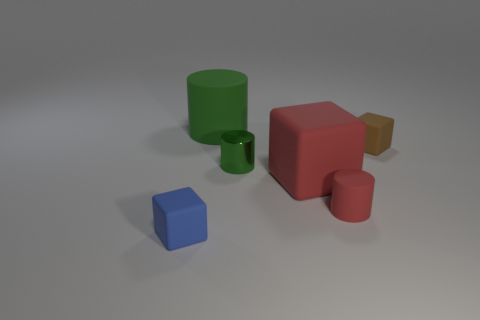What color is the other cylinder that is the same size as the green metallic cylinder?
Provide a short and direct response. Red. What shape is the matte thing that is the same color as the shiny thing?
Make the answer very short. Cylinder. Is the tiny red matte object the same shape as the green metallic thing?
Your answer should be very brief. Yes. There is a object that is to the left of the small green metal cylinder and behind the blue rubber block; what material is it made of?
Your answer should be compact. Rubber. What is the size of the blue cube?
Your response must be concise. Small. There is another large thing that is the same shape as the blue object; what color is it?
Give a very brief answer. Red. Is there anything else that has the same color as the metal thing?
Give a very brief answer. Yes. There is a cylinder behind the brown object; does it have the same size as the rubber block left of the large matte cylinder?
Offer a very short reply. No. Is the number of small rubber things in front of the metal cylinder the same as the number of small blue cubes in front of the blue matte cube?
Ensure brevity in your answer.  No. Does the shiny thing have the same size as the matte cylinder left of the large red rubber object?
Your answer should be very brief. No. 